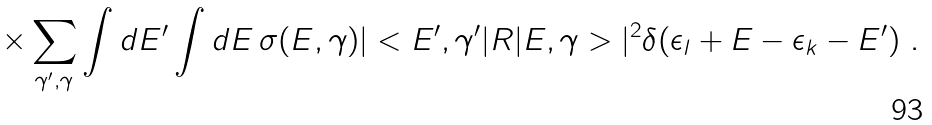<formula> <loc_0><loc_0><loc_500><loc_500>\times \sum _ { \gamma ^ { \prime } , \gamma } \int d E ^ { \prime } \int d E \, \sigma ( E , \gamma ) | < E ^ { \prime } , \gamma ^ { \prime } | R | E , \gamma > | ^ { 2 } \delta ( \epsilon _ { l } + E - \epsilon _ { k } - E ^ { \prime } ) \ .</formula> 